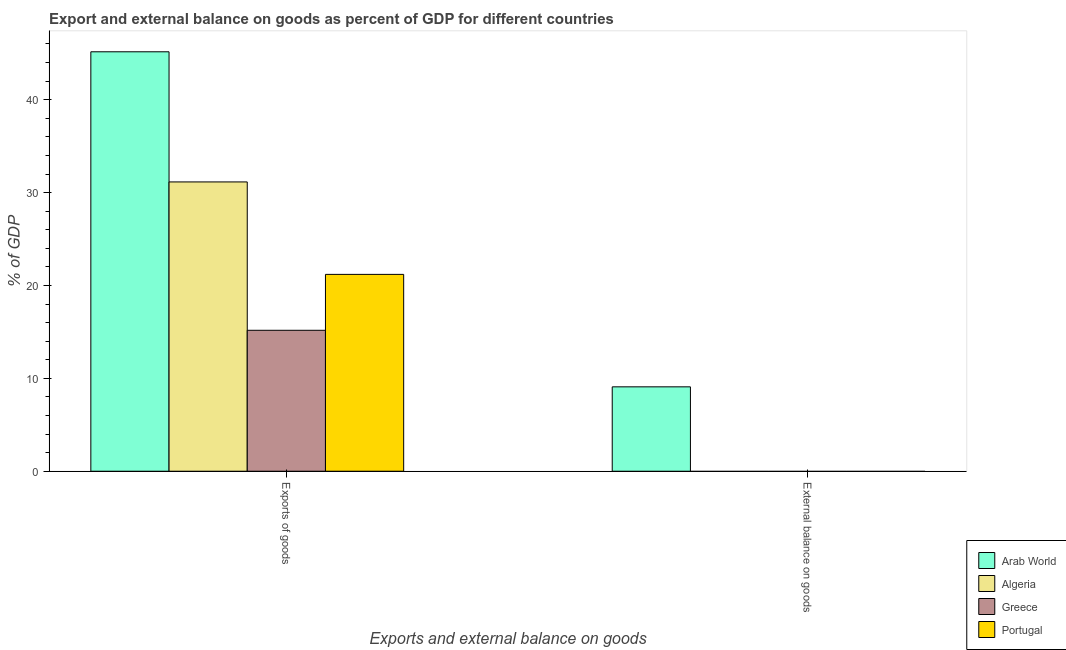Are the number of bars per tick equal to the number of legend labels?
Your answer should be very brief. No. Are the number of bars on each tick of the X-axis equal?
Give a very brief answer. No. What is the label of the 1st group of bars from the left?
Your response must be concise. Exports of goods. Across all countries, what is the maximum export of goods as percentage of gdp?
Provide a succinct answer. 45.16. Across all countries, what is the minimum export of goods as percentage of gdp?
Your response must be concise. 15.17. In which country was the external balance on goods as percentage of gdp maximum?
Provide a succinct answer. Arab World. What is the total export of goods as percentage of gdp in the graph?
Make the answer very short. 112.68. What is the difference between the export of goods as percentage of gdp in Greece and that in Arab World?
Provide a short and direct response. -29.99. What is the difference between the external balance on goods as percentage of gdp in Portugal and the export of goods as percentage of gdp in Greece?
Your answer should be compact. -15.17. What is the average export of goods as percentage of gdp per country?
Offer a terse response. 28.17. What is the ratio of the export of goods as percentage of gdp in Portugal to that in Arab World?
Make the answer very short. 0.47. What is the difference between two consecutive major ticks on the Y-axis?
Give a very brief answer. 10. Are the values on the major ticks of Y-axis written in scientific E-notation?
Provide a short and direct response. No. Does the graph contain any zero values?
Ensure brevity in your answer.  Yes. Does the graph contain grids?
Provide a succinct answer. No. How are the legend labels stacked?
Make the answer very short. Vertical. What is the title of the graph?
Your answer should be compact. Export and external balance on goods as percent of GDP for different countries. Does "Slovak Republic" appear as one of the legend labels in the graph?
Your answer should be compact. No. What is the label or title of the X-axis?
Make the answer very short. Exports and external balance on goods. What is the label or title of the Y-axis?
Keep it short and to the point. % of GDP. What is the % of GDP of Arab World in Exports of goods?
Offer a terse response. 45.16. What is the % of GDP of Algeria in Exports of goods?
Offer a very short reply. 31.15. What is the % of GDP in Greece in Exports of goods?
Offer a very short reply. 15.17. What is the % of GDP of Portugal in Exports of goods?
Make the answer very short. 21.19. What is the % of GDP of Arab World in External balance on goods?
Provide a succinct answer. 9.09. Across all Exports and external balance on goods, what is the maximum % of GDP in Arab World?
Your response must be concise. 45.16. Across all Exports and external balance on goods, what is the maximum % of GDP of Algeria?
Offer a terse response. 31.15. Across all Exports and external balance on goods, what is the maximum % of GDP of Greece?
Offer a very short reply. 15.17. Across all Exports and external balance on goods, what is the maximum % of GDP of Portugal?
Provide a short and direct response. 21.19. Across all Exports and external balance on goods, what is the minimum % of GDP of Arab World?
Give a very brief answer. 9.09. Across all Exports and external balance on goods, what is the minimum % of GDP in Algeria?
Provide a short and direct response. 0. What is the total % of GDP of Arab World in the graph?
Offer a very short reply. 54.25. What is the total % of GDP in Algeria in the graph?
Ensure brevity in your answer.  31.15. What is the total % of GDP of Greece in the graph?
Your answer should be very brief. 15.17. What is the total % of GDP in Portugal in the graph?
Give a very brief answer. 21.19. What is the difference between the % of GDP in Arab World in Exports of goods and that in External balance on goods?
Ensure brevity in your answer.  36.07. What is the average % of GDP in Arab World per Exports and external balance on goods?
Your answer should be very brief. 27.12. What is the average % of GDP of Algeria per Exports and external balance on goods?
Your answer should be very brief. 15.57. What is the average % of GDP of Greece per Exports and external balance on goods?
Ensure brevity in your answer.  7.59. What is the average % of GDP of Portugal per Exports and external balance on goods?
Provide a succinct answer. 10.6. What is the difference between the % of GDP in Arab World and % of GDP in Algeria in Exports of goods?
Make the answer very short. 14.01. What is the difference between the % of GDP in Arab World and % of GDP in Greece in Exports of goods?
Make the answer very short. 29.99. What is the difference between the % of GDP of Arab World and % of GDP of Portugal in Exports of goods?
Provide a succinct answer. 23.97. What is the difference between the % of GDP in Algeria and % of GDP in Greece in Exports of goods?
Offer a terse response. 15.97. What is the difference between the % of GDP of Algeria and % of GDP of Portugal in Exports of goods?
Ensure brevity in your answer.  9.95. What is the difference between the % of GDP of Greece and % of GDP of Portugal in Exports of goods?
Offer a terse response. -6.02. What is the ratio of the % of GDP of Arab World in Exports of goods to that in External balance on goods?
Your answer should be compact. 4.97. What is the difference between the highest and the second highest % of GDP of Arab World?
Your response must be concise. 36.07. What is the difference between the highest and the lowest % of GDP in Arab World?
Provide a succinct answer. 36.07. What is the difference between the highest and the lowest % of GDP of Algeria?
Ensure brevity in your answer.  31.15. What is the difference between the highest and the lowest % of GDP in Greece?
Provide a short and direct response. 15.17. What is the difference between the highest and the lowest % of GDP in Portugal?
Your response must be concise. 21.19. 